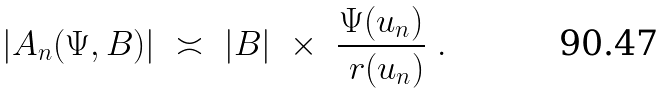<formula> <loc_0><loc_0><loc_500><loc_500>| A _ { n } ( \Psi , B ) | \ \asymp \ | B | \ \times \ \frac { \Psi ( u _ { n } ) } { \ r ( u _ { n } ) } \ .</formula> 